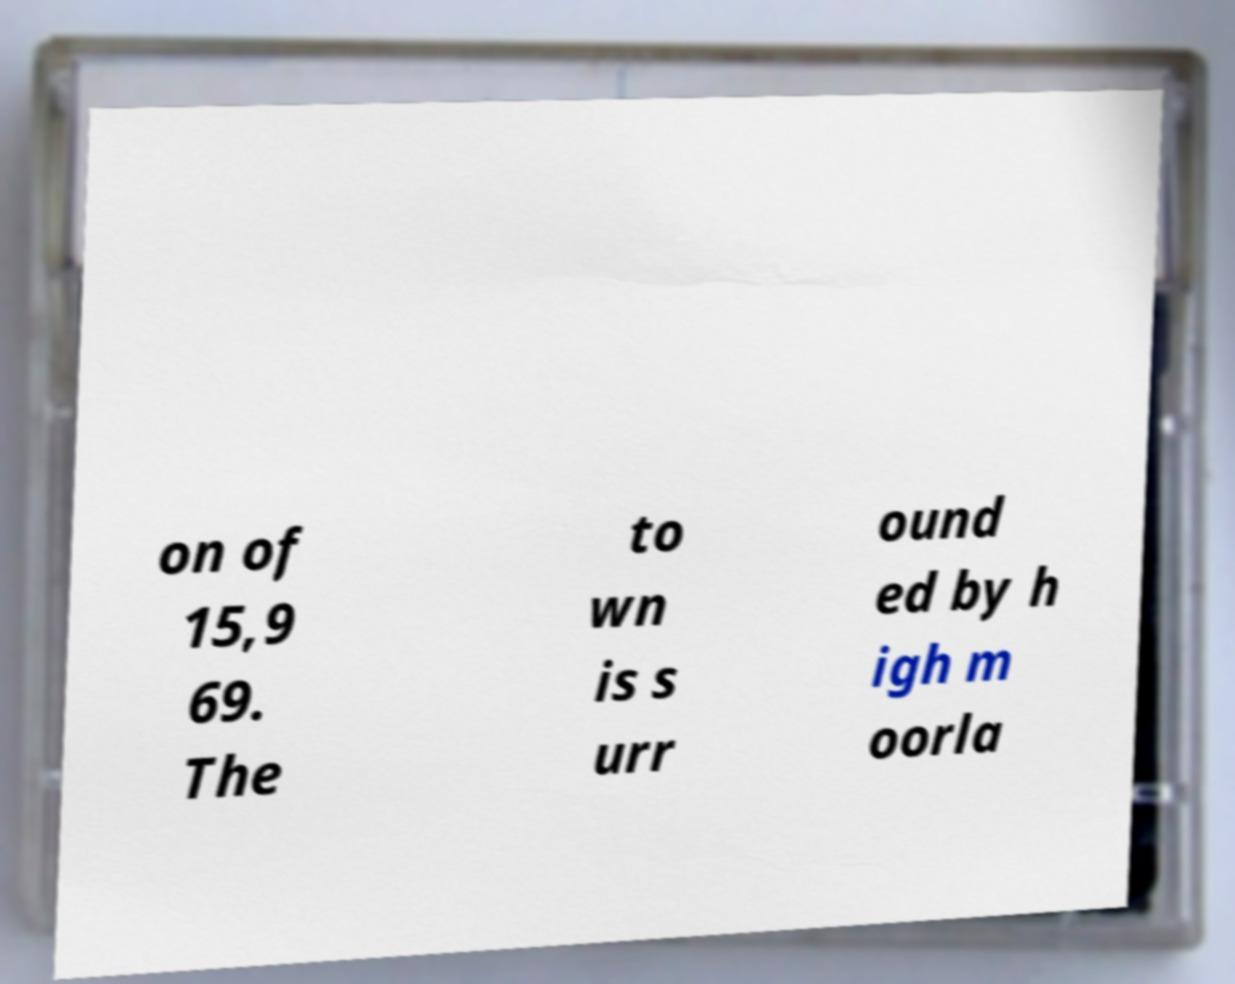I need the written content from this picture converted into text. Can you do that? on of 15,9 69. The to wn is s urr ound ed by h igh m oorla 